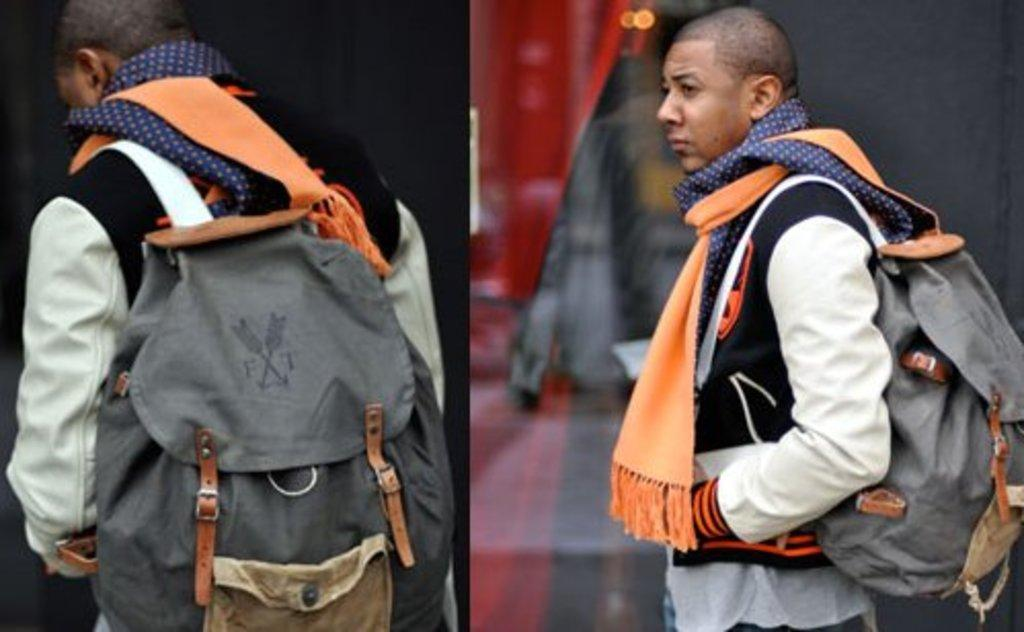<image>
Render a clear and concise summary of the photo. the letter F is on the backpack of the person 